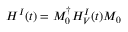Convert formula to latex. <formula><loc_0><loc_0><loc_500><loc_500>H ^ { I } ( t ) = M _ { 0 } ^ { \dagger } H _ { V } ^ { I } ( t ) M _ { 0 }</formula> 